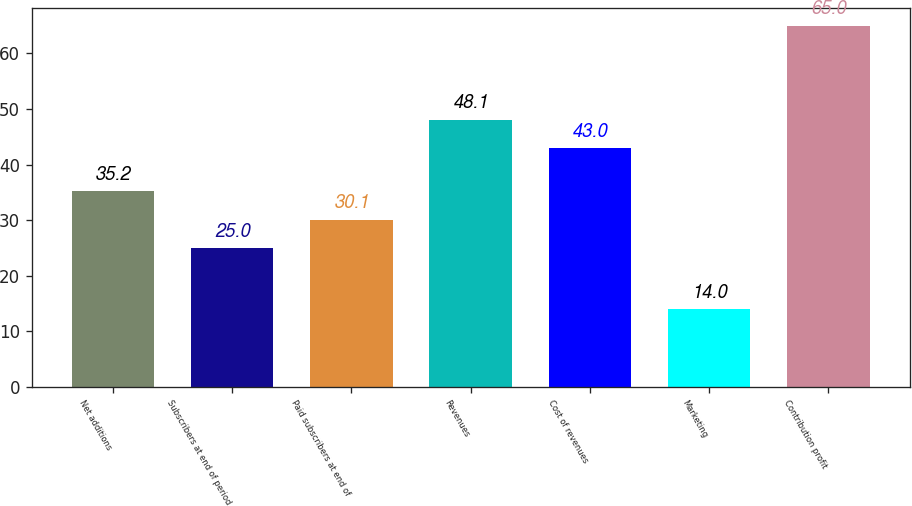<chart> <loc_0><loc_0><loc_500><loc_500><bar_chart><fcel>Net additions<fcel>Subscribers at end of period<fcel>Paid subscribers at end of<fcel>Revenues<fcel>Cost of revenues<fcel>Marketing<fcel>Contribution profit<nl><fcel>35.2<fcel>25<fcel>30.1<fcel>48.1<fcel>43<fcel>14<fcel>65<nl></chart> 